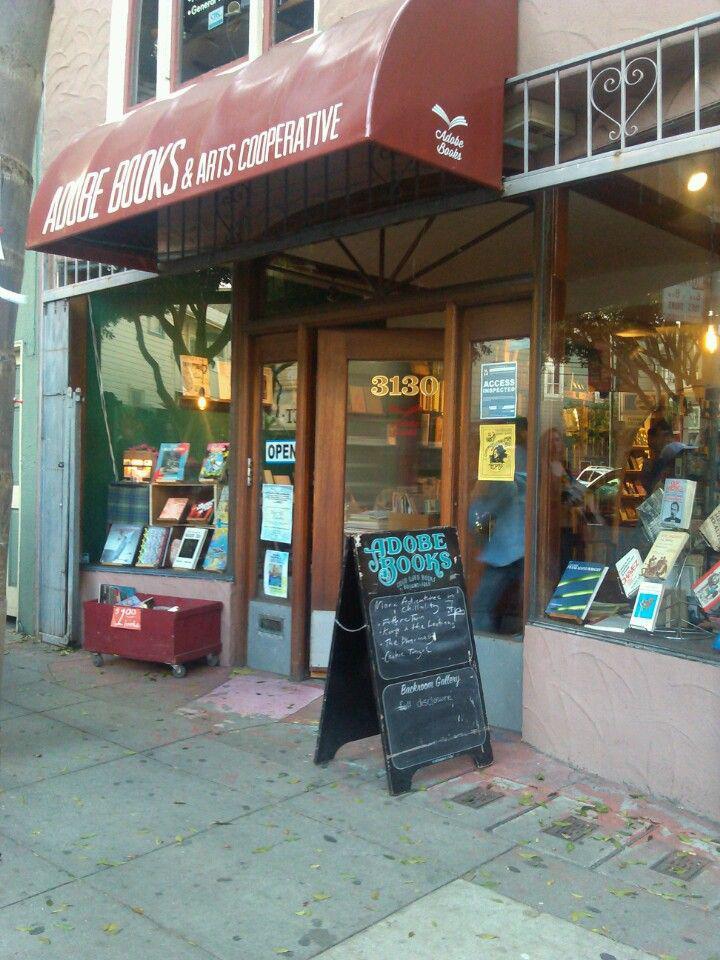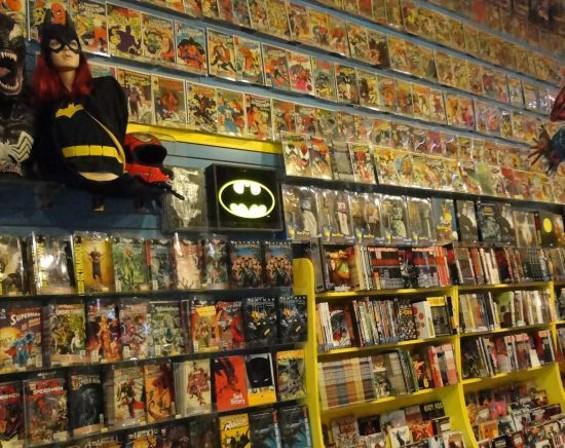The first image is the image on the left, the second image is the image on the right. Examine the images to the left and right. Is the description "There are two set of red bookshelves outside filled with books, under a red awning." accurate? Answer yes or no. No. The first image is the image on the left, the second image is the image on the right. For the images shown, is this caption "An awning hangs over the business in the image on the right." true? Answer yes or no. No. 